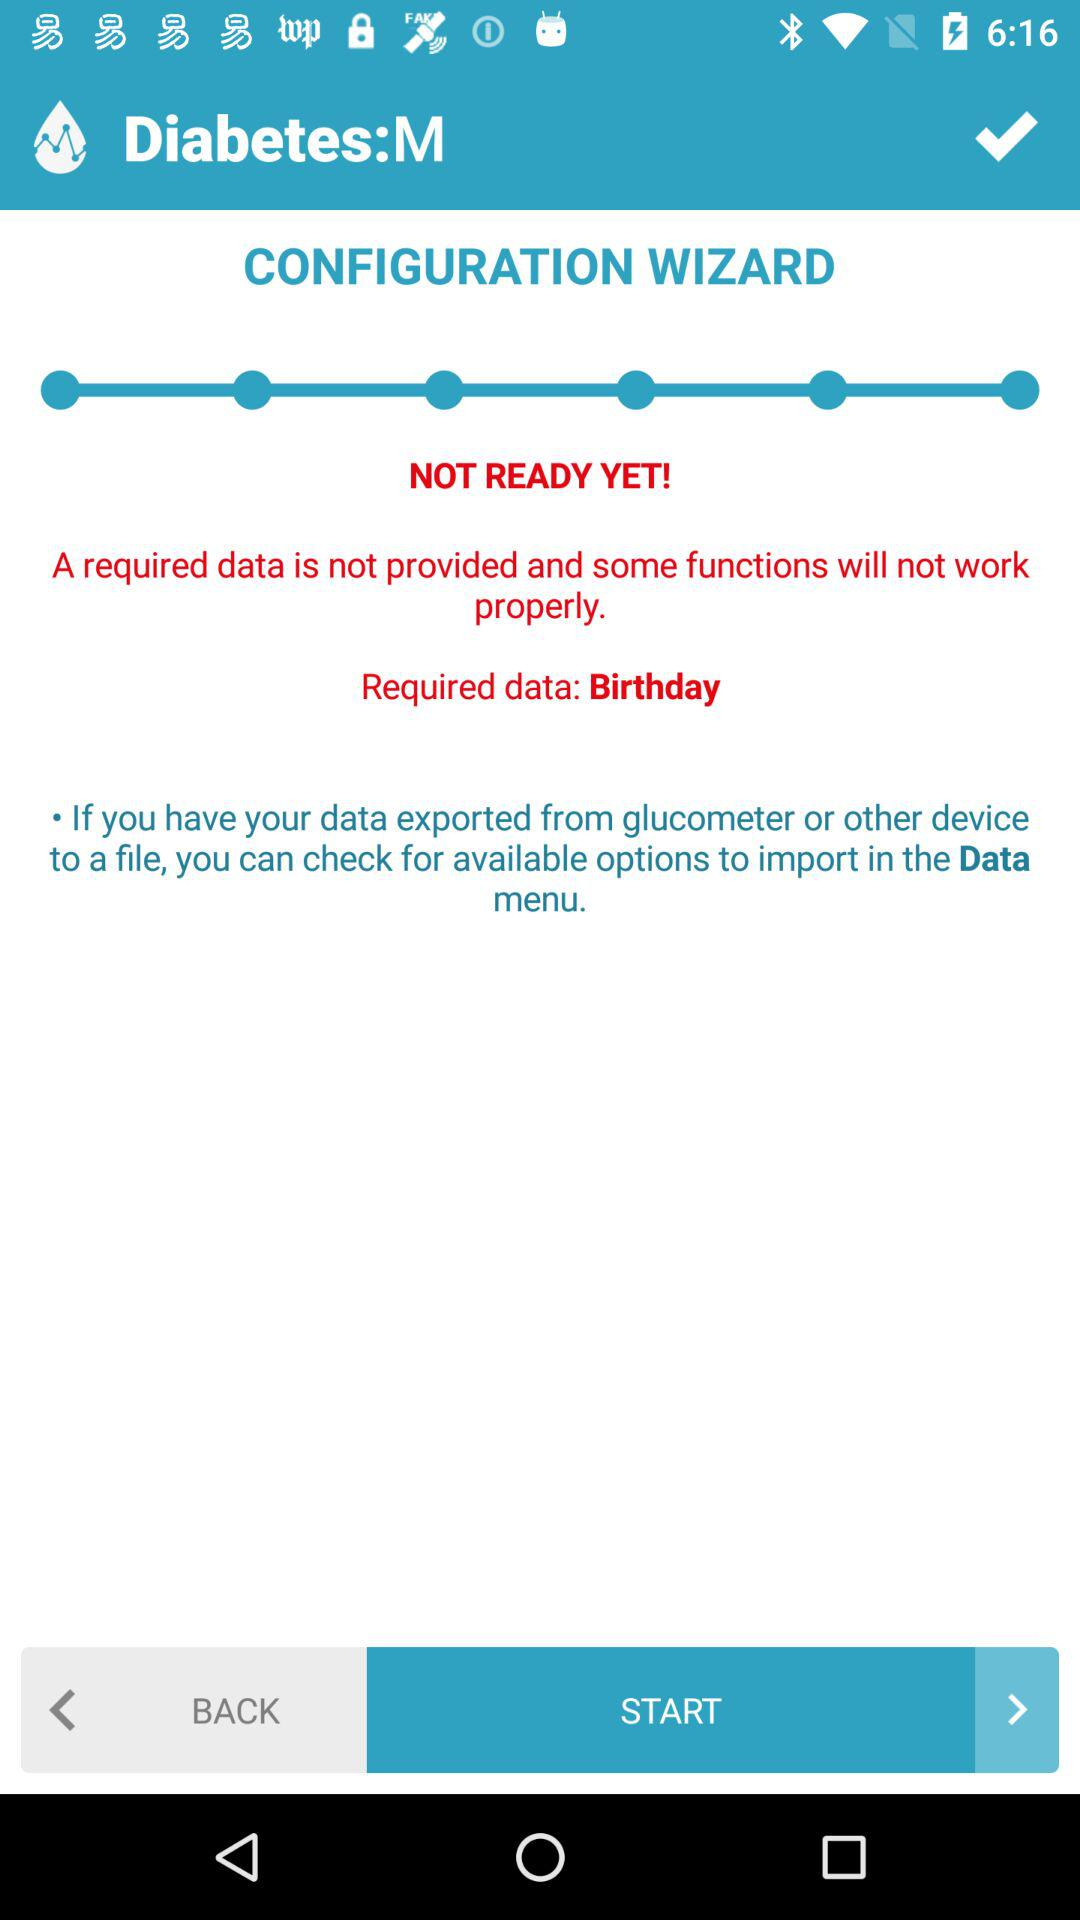How many required data are missing?
Answer the question using a single word or phrase. 1 